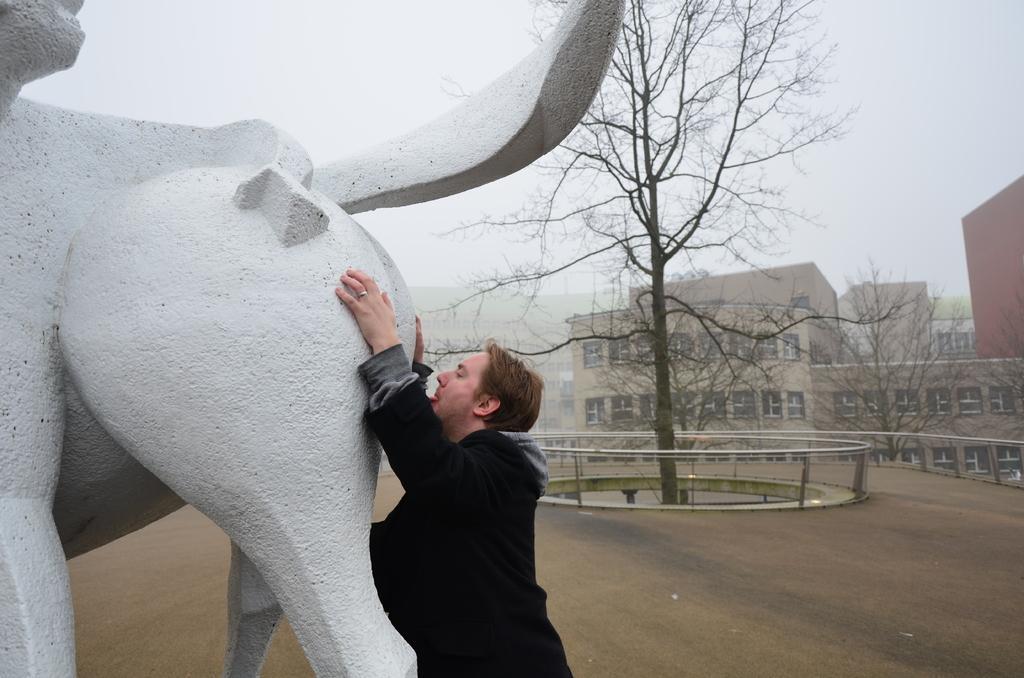Please provide a concise description of this image. In this image there is the sky, there are buildings, there is a tree truncated towards the top of the image, there is the road, there is water, there is a person truncated towards the bottom of the image, there is a sculptor truncated towards the left of the image. 